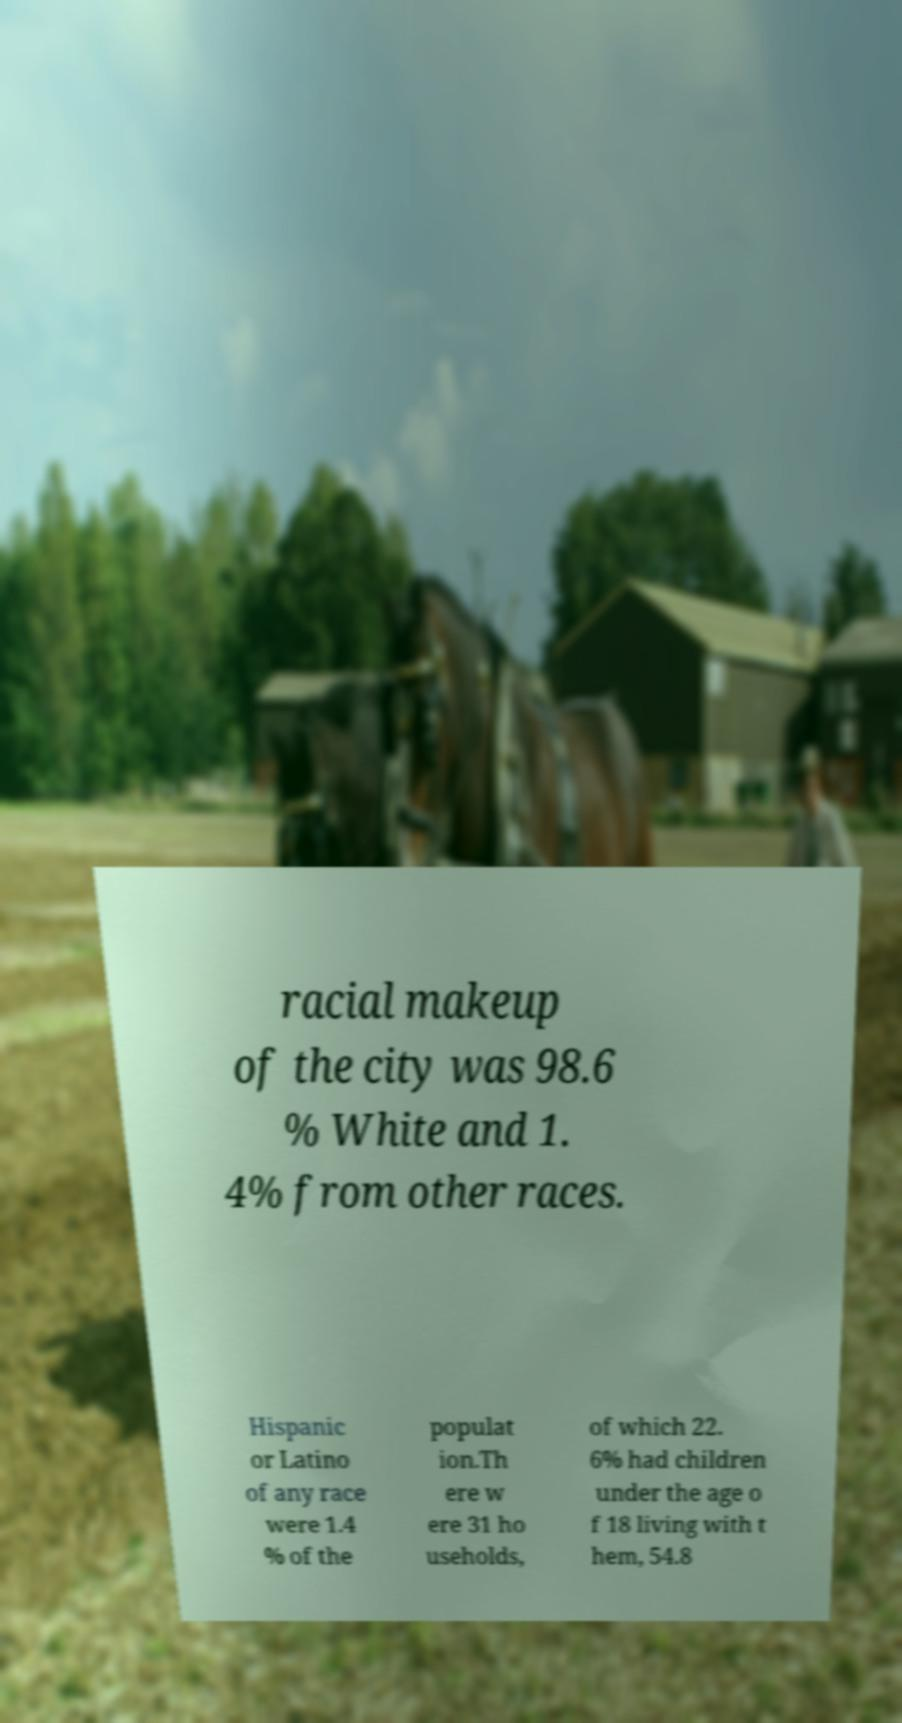Can you accurately transcribe the text from the provided image for me? racial makeup of the city was 98.6 % White and 1. 4% from other races. Hispanic or Latino of any race were 1.4 % of the populat ion.Th ere w ere 31 ho useholds, of which 22. 6% had children under the age o f 18 living with t hem, 54.8 